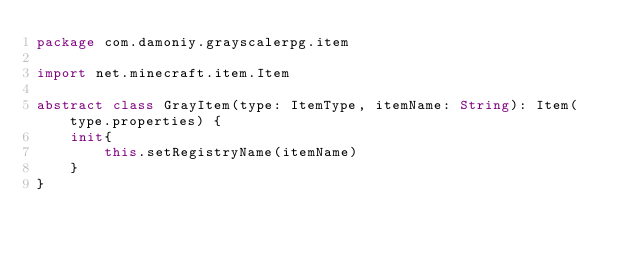<code> <loc_0><loc_0><loc_500><loc_500><_Kotlin_>package com.damoniy.grayscalerpg.item

import net.minecraft.item.Item

abstract class GrayItem(type: ItemType, itemName: String): Item(type.properties) {
    init{
        this.setRegistryName(itemName)
    }
}</code> 